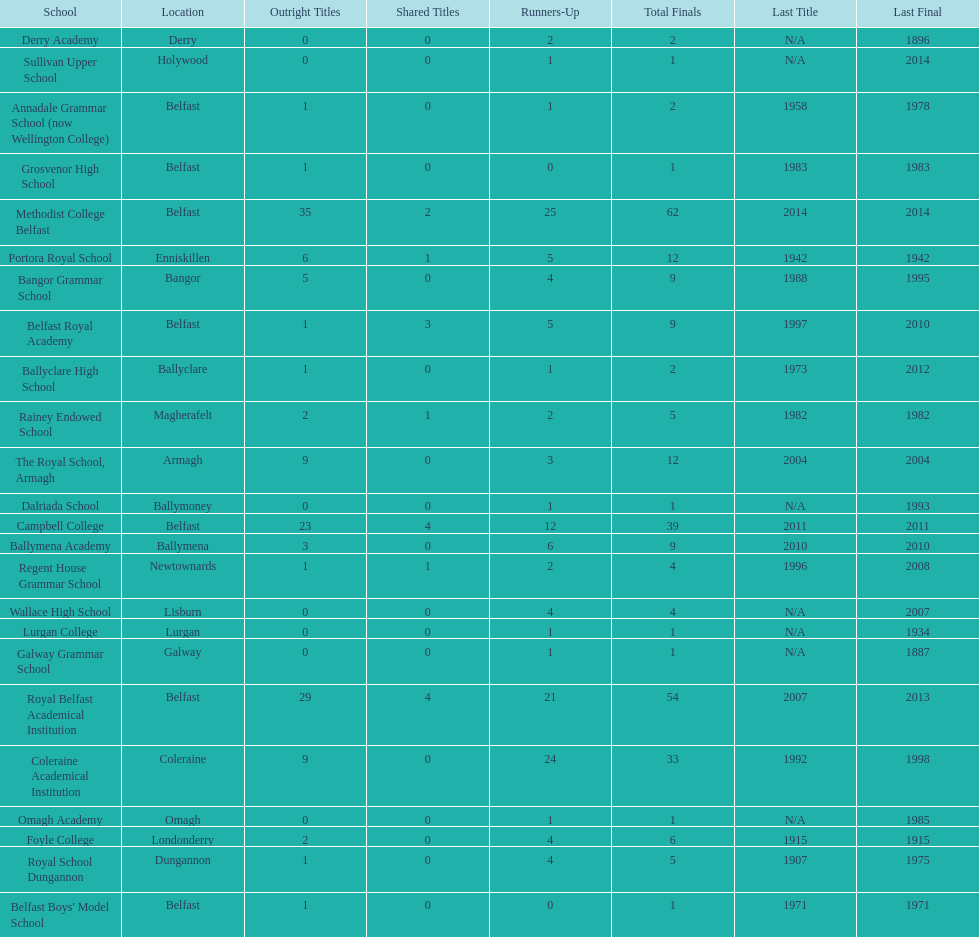How many schools have at least 5 outright titles? 7. 